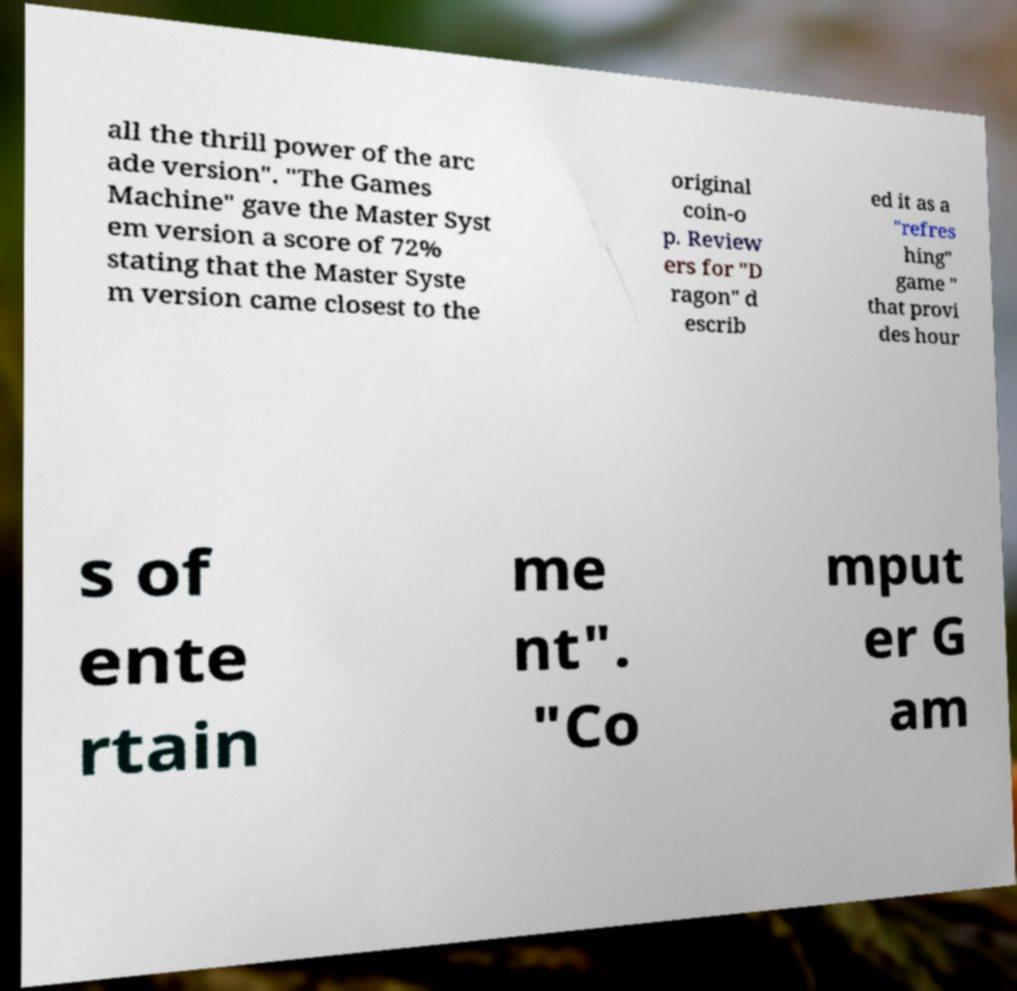Could you assist in decoding the text presented in this image and type it out clearly? all the thrill power of the arc ade version". "The Games Machine" gave the Master Syst em version a score of 72% stating that the Master Syste m version came closest to the original coin-o p. Review ers for "D ragon" d escrib ed it as a "refres hing" game " that provi des hour s of ente rtain me nt". "Co mput er G am 